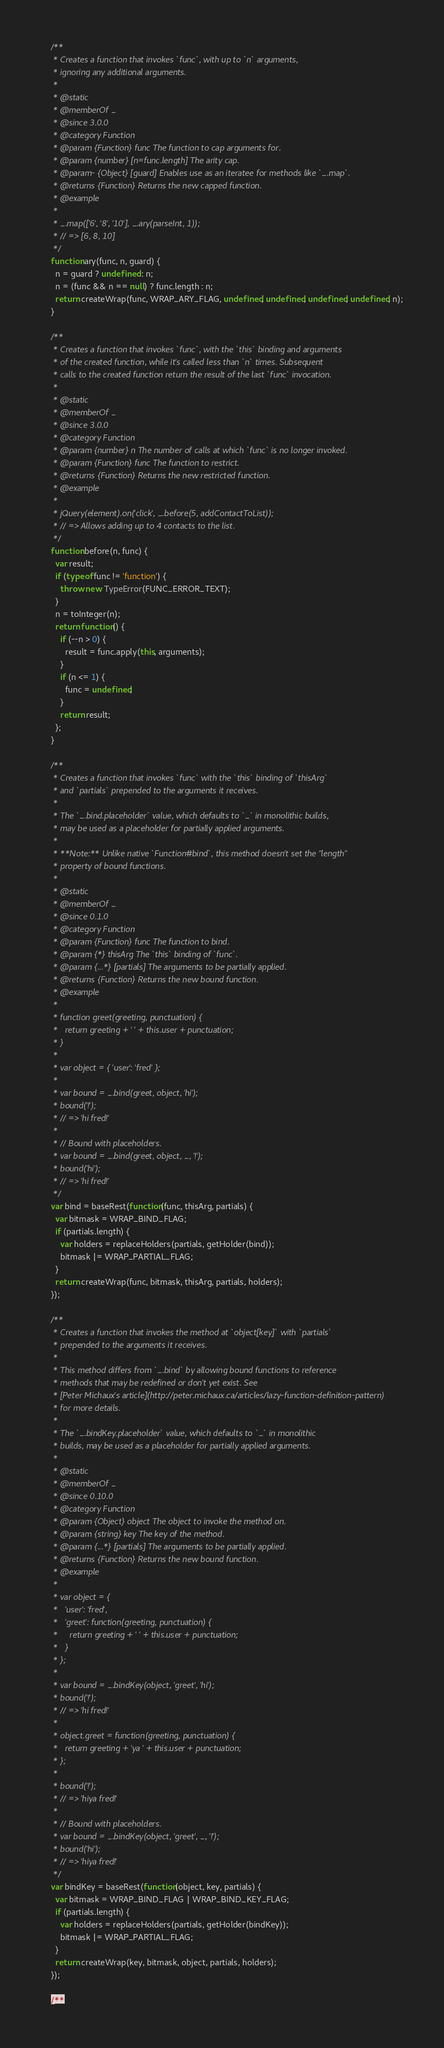Convert code to text. <code><loc_0><loc_0><loc_500><loc_500><_JavaScript_>
    /**
     * Creates a function that invokes `func`, with up to `n` arguments,
     * ignoring any additional arguments.
     *
     * @static
     * @memberOf _
     * @since 3.0.0
     * @category Function
     * @param {Function} func The function to cap arguments for.
     * @param {number} [n=func.length] The arity cap.
     * @param- {Object} [guard] Enables use as an iteratee for methods like `_.map`.
     * @returns {Function} Returns the new capped function.
     * @example
     *
     * _.map(['6', '8', '10'], _.ary(parseInt, 1));
     * // => [6, 8, 10]
     */
    function ary(func, n, guard) {
      n = guard ? undefined : n;
      n = (func && n == null) ? func.length : n;
      return createWrap(func, WRAP_ARY_FLAG, undefined, undefined, undefined, undefined, n);
    }

    /**
     * Creates a function that invokes `func`, with the `this` binding and arguments
     * of the created function, while it's called less than `n` times. Subsequent
     * calls to the created function return the result of the last `func` invocation.
     *
     * @static
     * @memberOf _
     * @since 3.0.0
     * @category Function
     * @param {number} n The number of calls at which `func` is no longer invoked.
     * @param {Function} func The function to restrict.
     * @returns {Function} Returns the new restricted function.
     * @example
     *
     * jQuery(element).on('click', _.before(5, addContactToList));
     * // => Allows adding up to 4 contacts to the list.
     */
    function before(n, func) {
      var result;
      if (typeof func != 'function') {
        throw new TypeError(FUNC_ERROR_TEXT);
      }
      n = toInteger(n);
      return function() {
        if (--n > 0) {
          result = func.apply(this, arguments);
        }
        if (n <= 1) {
          func = undefined;
        }
        return result;
      };
    }

    /**
     * Creates a function that invokes `func` with the `this` binding of `thisArg`
     * and `partials` prepended to the arguments it receives.
     *
     * The `_.bind.placeholder` value, which defaults to `_` in monolithic builds,
     * may be used as a placeholder for partially applied arguments.
     *
     * **Note:** Unlike native `Function#bind`, this method doesn't set the "length"
     * property of bound functions.
     *
     * @static
     * @memberOf _
     * @since 0.1.0
     * @category Function
     * @param {Function} func The function to bind.
     * @param {*} thisArg The `this` binding of `func`.
     * @param {...*} [partials] The arguments to be partially applied.
     * @returns {Function} Returns the new bound function.
     * @example
     *
     * function greet(greeting, punctuation) {
     *   return greeting + ' ' + this.user + punctuation;
     * }
     *
     * var object = { 'user': 'fred' };
     *
     * var bound = _.bind(greet, object, 'hi');
     * bound('!');
     * // => 'hi fred!'
     *
     * // Bound with placeholders.
     * var bound = _.bind(greet, object, _, '!');
     * bound('hi');
     * // => 'hi fred!'
     */
    var bind = baseRest(function(func, thisArg, partials) {
      var bitmask = WRAP_BIND_FLAG;
      if (partials.length) {
        var holders = replaceHolders(partials, getHolder(bind));
        bitmask |= WRAP_PARTIAL_FLAG;
      }
      return createWrap(func, bitmask, thisArg, partials, holders);
    });

    /**
     * Creates a function that invokes the method at `object[key]` with `partials`
     * prepended to the arguments it receives.
     *
     * This method differs from `_.bind` by allowing bound functions to reference
     * methods that may be redefined or don't yet exist. See
     * [Peter Michaux's article](http://peter.michaux.ca/articles/lazy-function-definition-pattern)
     * for more details.
     *
     * The `_.bindKey.placeholder` value, which defaults to `_` in monolithic
     * builds, may be used as a placeholder for partially applied arguments.
     *
     * @static
     * @memberOf _
     * @since 0.10.0
     * @category Function
     * @param {Object} object The object to invoke the method on.
     * @param {string} key The key of the method.
     * @param {...*} [partials] The arguments to be partially applied.
     * @returns {Function} Returns the new bound function.
     * @example
     *
     * var object = {
     *   'user': 'fred',
     *   'greet': function(greeting, punctuation) {
     *     return greeting + ' ' + this.user + punctuation;
     *   }
     * };
     *
     * var bound = _.bindKey(object, 'greet', 'hi');
     * bound('!');
     * // => 'hi fred!'
     *
     * object.greet = function(greeting, punctuation) {
     *   return greeting + 'ya ' + this.user + punctuation;
     * };
     *
     * bound('!');
     * // => 'hiya fred!'
     *
     * // Bound with placeholders.
     * var bound = _.bindKey(object, 'greet', _, '!');
     * bound('hi');
     * // => 'hiya fred!'
     */
    var bindKey = baseRest(function(object, key, partials) {
      var bitmask = WRAP_BIND_FLAG | WRAP_BIND_KEY_FLAG;
      if (partials.length) {
        var holders = replaceHolders(partials, getHolder(bindKey));
        bitmask |= WRAP_PARTIAL_FLAG;
      }
      return createWrap(key, bitmask, object, partials, holders);
    });

    /**</code> 